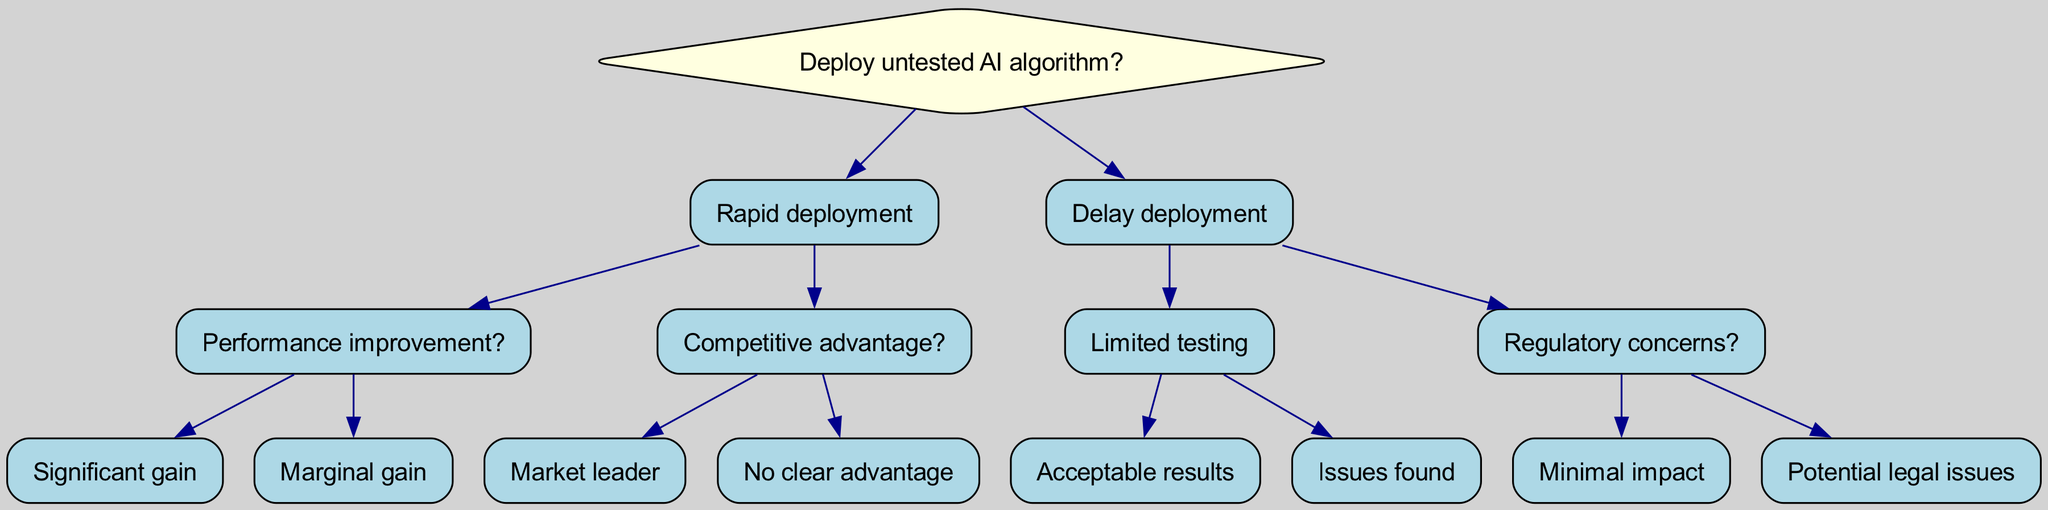What is the root node of the diagram? The root node is the topmost node in the decision tree, which represents the main question or decision being considered. In this case, the root node is "Deploy untested AI algorithm?"
Answer: Deploy untested AI algorithm? How many child nodes does the root have? The root node has two child nodes, which are "Rapid deployment" and "Delay deployment." Therefore, we can count these to determine the number of branches stemming from the root.
Answer: 2 What is the outcome if there is a significant performance gain? According to the decision tree, if there is a significant gain in performance after deploying the untested AI algorithm, the outcome is straightforward. It indicates immediate action.
Answer: Deploy immediately Which decision leads to "Seek legal counsel"? To reach the outcome "Seek legal counsel," you start from the root and go through "Delay deployment" to "Regulatory concerns?" and finally to "Potential legal issues." This series of decisions culminates in needing legal advice concerning potential regulatory impacts.
Answer: Regulatory concerns → Potential legal issues What is the final outcome if limited testing results show issues? If limited testing shows issues after delaying deployment, the outcome is to "Refine algorithm." This indicates that the testing phase reveals problems that need to be addressed before proceeding further.
Answer: Refine algorithm What node directly follows "Competitive advantage?" if the answer is "Market leader"? In the decision tree, if "Competitive advantage?" results in "Market leader," it leads directly to the outcome of "Release ASAP." This indicates a clear action based on the competitive landscape.
Answer: Release ASAP How many total outcomes are represented in the diagram? To determine the total outcomes, we count the leaf nodes or terminal nodes where decisions lead to final actions. Based on the tree structure, we have four key outcomes: "Deploy immediately," "Monitor closely," "Release ASAP," and "Seek legal counsel."
Answer: 4 What happens if there are acceptable results in limited testing? The decision tree indicates that if the results are acceptable after limited testing, the specific action is to "Deploy with caution." This suggests a balanced approach to decision-making, promoting caution despite acceptable performance.
Answer: Deploy with caution If the answer to "Performance improvement?" is "Marginal gain," what should be done next? The decision tree states that if the performance improvement is marginal, the recommended action is to "Monitor closely." This suggests ongoing observation before making further decisions on deployment.
Answer: Monitor closely 